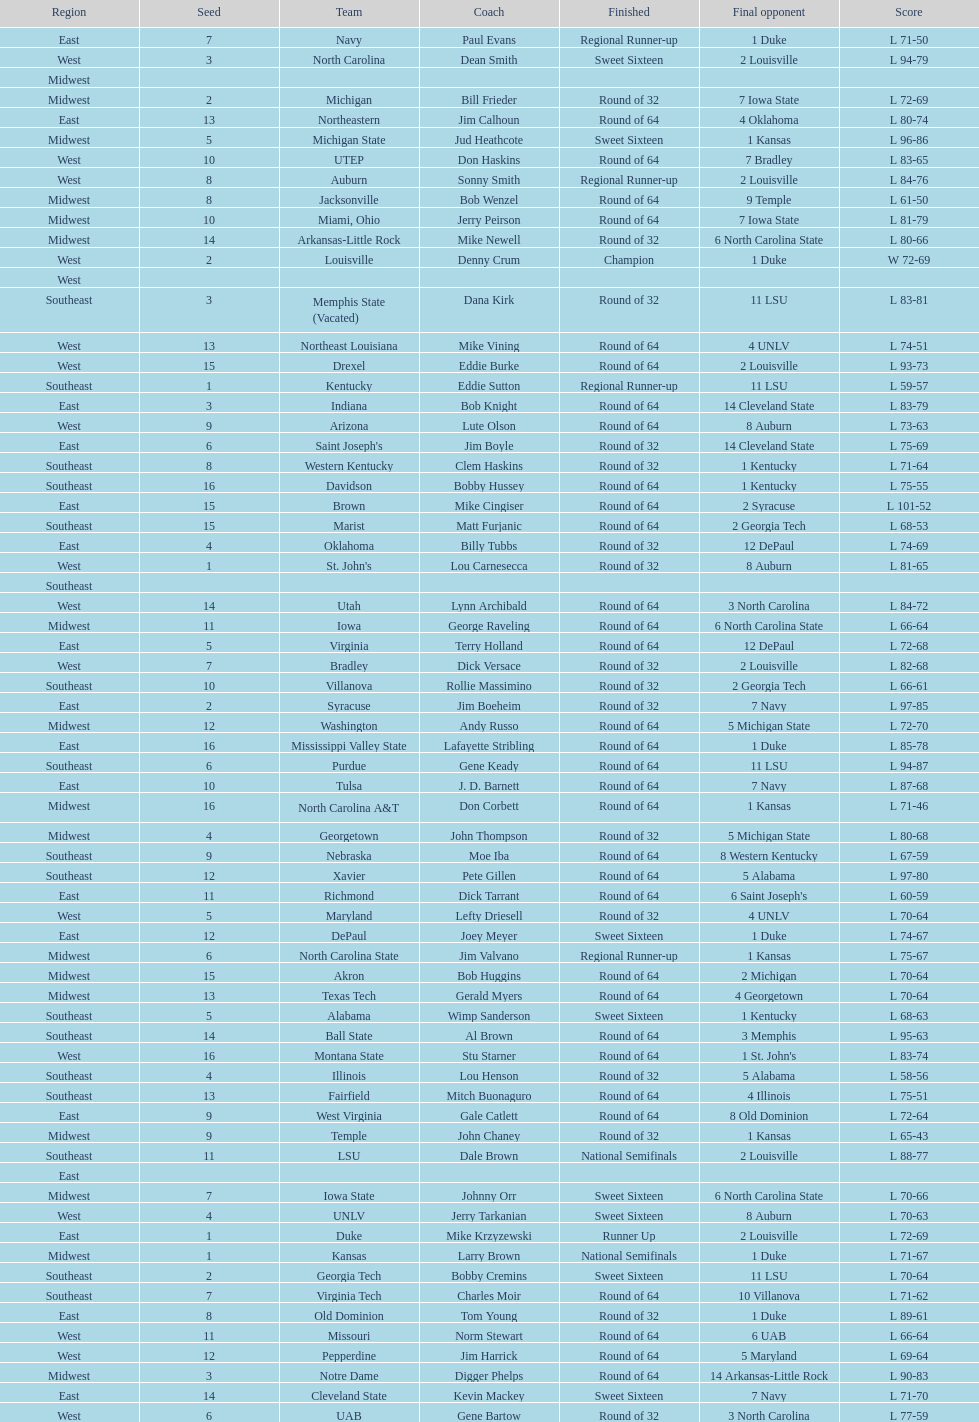Would you mind parsing the complete table? {'header': ['Region', 'Seed', 'Team', 'Coach', 'Finished', 'Final opponent', 'Score'], 'rows': [['East', '7', 'Navy', 'Paul Evans', 'Regional Runner-up', '1 Duke', 'L 71-50'], ['West', '3', 'North Carolina', 'Dean Smith', 'Sweet Sixteen', '2 Louisville', 'L 94-79'], ['Midwest', '', '', '', '', '', ''], ['Midwest', '2', 'Michigan', 'Bill Frieder', 'Round of 32', '7 Iowa State', 'L 72-69'], ['East', '13', 'Northeastern', 'Jim Calhoun', 'Round of 64', '4 Oklahoma', 'L 80-74'], ['Midwest', '5', 'Michigan State', 'Jud Heathcote', 'Sweet Sixteen', '1 Kansas', 'L 96-86'], ['West', '10', 'UTEP', 'Don Haskins', 'Round of 64', '7 Bradley', 'L 83-65'], ['West', '8', 'Auburn', 'Sonny Smith', 'Regional Runner-up', '2 Louisville', 'L 84-76'], ['Midwest', '8', 'Jacksonville', 'Bob Wenzel', 'Round of 64', '9 Temple', 'L 61-50'], ['Midwest', '10', 'Miami, Ohio', 'Jerry Peirson', 'Round of 64', '7 Iowa State', 'L 81-79'], ['Midwest', '14', 'Arkansas-Little Rock', 'Mike Newell', 'Round of 32', '6 North Carolina State', 'L 80-66'], ['West', '2', 'Louisville', 'Denny Crum', 'Champion', '1 Duke', 'W 72-69'], ['West', '', '', '', '', '', ''], ['Southeast', '3', 'Memphis State (Vacated)', 'Dana Kirk', 'Round of 32', '11 LSU', 'L 83-81'], ['West', '13', 'Northeast Louisiana', 'Mike Vining', 'Round of 64', '4 UNLV', 'L 74-51'], ['West', '15', 'Drexel', 'Eddie Burke', 'Round of 64', '2 Louisville', 'L 93-73'], ['Southeast', '1', 'Kentucky', 'Eddie Sutton', 'Regional Runner-up', '11 LSU', 'L 59-57'], ['East', '3', 'Indiana', 'Bob Knight', 'Round of 64', '14 Cleveland State', 'L 83-79'], ['West', '9', 'Arizona', 'Lute Olson', 'Round of 64', '8 Auburn', 'L 73-63'], ['East', '6', "Saint Joseph's", 'Jim Boyle', 'Round of 32', '14 Cleveland State', 'L 75-69'], ['Southeast', '8', 'Western Kentucky', 'Clem Haskins', 'Round of 32', '1 Kentucky', 'L 71-64'], ['Southeast', '16', 'Davidson', 'Bobby Hussey', 'Round of 64', '1 Kentucky', 'L 75-55'], ['East', '15', 'Brown', 'Mike Cingiser', 'Round of 64', '2 Syracuse', 'L 101-52'], ['Southeast', '15', 'Marist', 'Matt Furjanic', 'Round of 64', '2 Georgia Tech', 'L 68-53'], ['East', '4', 'Oklahoma', 'Billy Tubbs', 'Round of 32', '12 DePaul', 'L 74-69'], ['West', '1', "St. John's", 'Lou Carnesecca', 'Round of 32', '8 Auburn', 'L 81-65'], ['Southeast', '', '', '', '', '', ''], ['West', '14', 'Utah', 'Lynn Archibald', 'Round of 64', '3 North Carolina', 'L 84-72'], ['Midwest', '11', 'Iowa', 'George Raveling', 'Round of 64', '6 North Carolina State', 'L 66-64'], ['East', '5', 'Virginia', 'Terry Holland', 'Round of 64', '12 DePaul', 'L 72-68'], ['West', '7', 'Bradley', 'Dick Versace', 'Round of 32', '2 Louisville', 'L 82-68'], ['Southeast', '10', 'Villanova', 'Rollie Massimino', 'Round of 32', '2 Georgia Tech', 'L 66-61'], ['East', '2', 'Syracuse', 'Jim Boeheim', 'Round of 32', '7 Navy', 'L 97-85'], ['Midwest', '12', 'Washington', 'Andy Russo', 'Round of 64', '5 Michigan State', 'L 72-70'], ['East', '16', 'Mississippi Valley State', 'Lafayette Stribling', 'Round of 64', '1 Duke', 'L 85-78'], ['Southeast', '6', 'Purdue', 'Gene Keady', 'Round of 64', '11 LSU', 'L 94-87'], ['East', '10', 'Tulsa', 'J. D. Barnett', 'Round of 64', '7 Navy', 'L 87-68'], ['Midwest', '16', 'North Carolina A&T', 'Don Corbett', 'Round of 64', '1 Kansas', 'L 71-46'], ['Midwest', '4', 'Georgetown', 'John Thompson', 'Round of 32', '5 Michigan State', 'L 80-68'], ['Southeast', '9', 'Nebraska', 'Moe Iba', 'Round of 64', '8 Western Kentucky', 'L 67-59'], ['Southeast', '12', 'Xavier', 'Pete Gillen', 'Round of 64', '5 Alabama', 'L 97-80'], ['East', '11', 'Richmond', 'Dick Tarrant', 'Round of 64', "6 Saint Joseph's", 'L 60-59'], ['West', '5', 'Maryland', 'Lefty Driesell', 'Round of 32', '4 UNLV', 'L 70-64'], ['East', '12', 'DePaul', 'Joey Meyer', 'Sweet Sixteen', '1 Duke', 'L 74-67'], ['Midwest', '6', 'North Carolina State', 'Jim Valvano', 'Regional Runner-up', '1 Kansas', 'L 75-67'], ['Midwest', '15', 'Akron', 'Bob Huggins', 'Round of 64', '2 Michigan', 'L 70-64'], ['Midwest', '13', 'Texas Tech', 'Gerald Myers', 'Round of 64', '4 Georgetown', 'L 70-64'], ['Southeast', '5', 'Alabama', 'Wimp Sanderson', 'Sweet Sixteen', '1 Kentucky', 'L 68-63'], ['Southeast', '14', 'Ball State', 'Al Brown', 'Round of 64', '3 Memphis', 'L 95-63'], ['West', '16', 'Montana State', 'Stu Starner', 'Round of 64', "1 St. John's", 'L 83-74'], ['Southeast', '4', 'Illinois', 'Lou Henson', 'Round of 32', '5 Alabama', 'L 58-56'], ['Southeast', '13', 'Fairfield', 'Mitch Buonaguro', 'Round of 64', '4 Illinois', 'L 75-51'], ['East', '9', 'West Virginia', 'Gale Catlett', 'Round of 64', '8 Old Dominion', 'L 72-64'], ['Midwest', '9', 'Temple', 'John Chaney', 'Round of 32', '1 Kansas', 'L 65-43'], ['Southeast', '11', 'LSU', 'Dale Brown', 'National Semifinals', '2 Louisville', 'L 88-77'], ['East', '', '', '', '', '', ''], ['Midwest', '7', 'Iowa State', 'Johnny Orr', 'Sweet Sixteen', '6 North Carolina State', 'L 70-66'], ['West', '4', 'UNLV', 'Jerry Tarkanian', 'Sweet Sixteen', '8 Auburn', 'L 70-63'], ['East', '1', 'Duke', 'Mike Krzyzewski', 'Runner Up', '2 Louisville', 'L 72-69'], ['Midwest', '1', 'Kansas', 'Larry Brown', 'National Semifinals', '1 Duke', 'L 71-67'], ['Southeast', '2', 'Georgia Tech', 'Bobby Cremins', 'Sweet Sixteen', '11 LSU', 'L 70-64'], ['Southeast', '7', 'Virginia Tech', 'Charles Moir', 'Round of 64', '10 Villanova', 'L 71-62'], ['East', '8', 'Old Dominion', 'Tom Young', 'Round of 32', '1 Duke', 'L 89-61'], ['West', '11', 'Missouri', 'Norm Stewart', 'Round of 64', '6 UAB', 'L 66-64'], ['West', '12', 'Pepperdine', 'Jim Harrick', 'Round of 64', '5 Maryland', 'L 69-64'], ['Midwest', '3', 'Notre Dame', 'Digger Phelps', 'Round of 64', '14 Arkansas-Little Rock', 'L 90-83'], ['East', '14', 'Cleveland State', 'Kevin Mackey', 'Sweet Sixteen', '7 Navy', 'L 71-70'], ['West', '6', 'UAB', 'Gene Bartow', 'Round of 32', '3 North Carolina', 'L 77-59']]} How many number of teams played altogether? 64. 